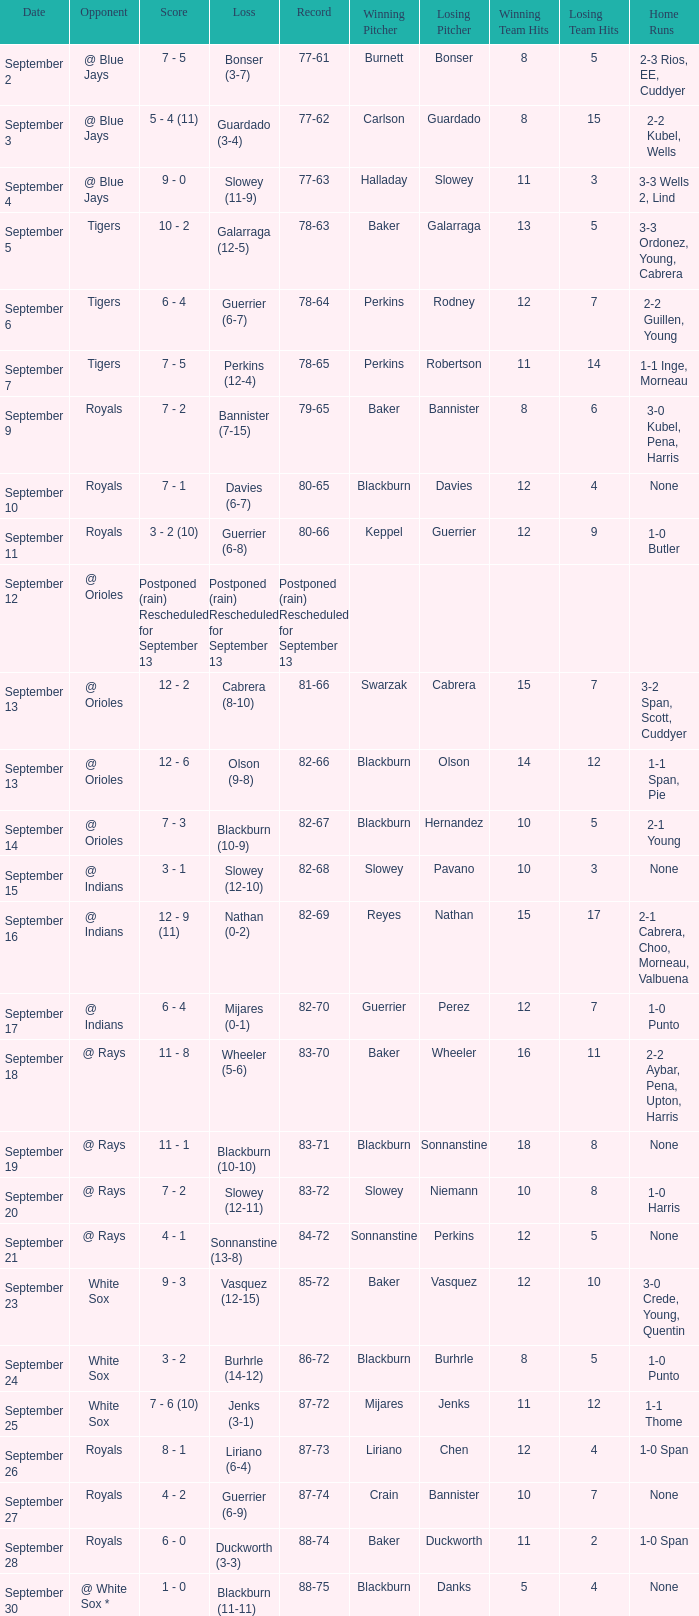What date has the record of 77-62? September 3. 